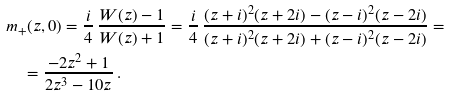Convert formula to latex. <formula><loc_0><loc_0><loc_500><loc_500>& m _ { + } ( z , 0 ) = \frac { i } { 4 } \, \frac { W ( z ) - 1 } { W ( z ) + 1 } = \frac { i } { 4 } \, \frac { ( z + i ) ^ { 2 } ( z + 2 i ) - ( z - i ) ^ { 2 } ( z - 2 i ) } { ( z + i ) ^ { 2 } ( z + 2 i ) + ( z - i ) ^ { 2 } ( z - 2 i ) } = \\ & \quad = \frac { - 2 z ^ { 2 } + 1 } { 2 z ^ { 3 } - 1 0 z } \, .</formula> 